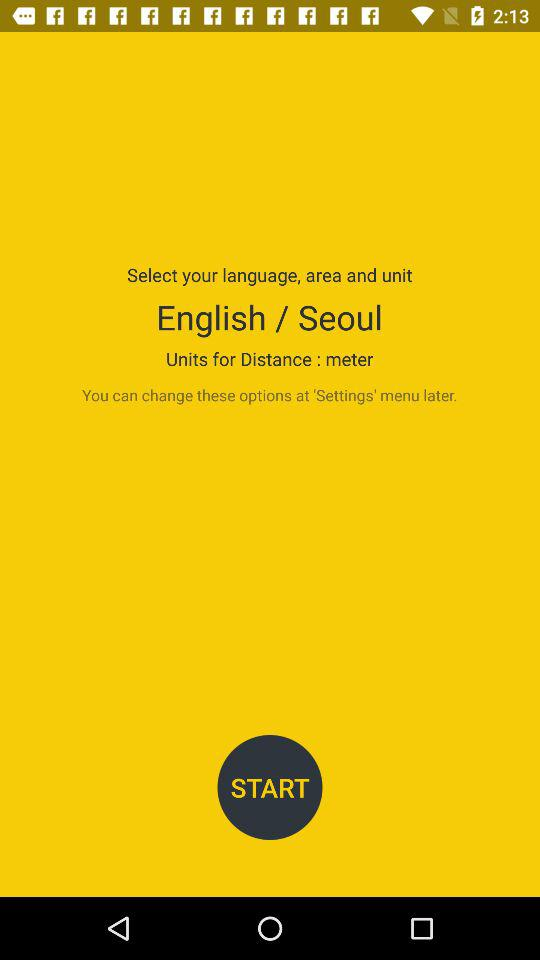How many units are available for distance?
Answer the question using a single word or phrase. 1 